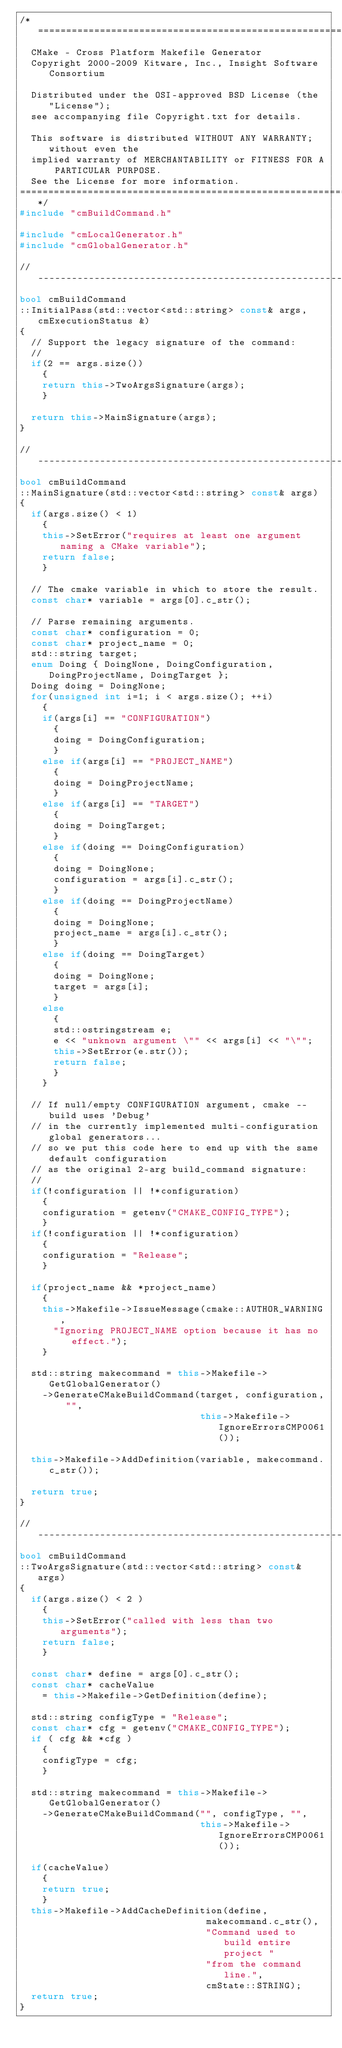Convert code to text. <code><loc_0><loc_0><loc_500><loc_500><_C++_>/*============================================================================
  CMake - Cross Platform Makefile Generator
  Copyright 2000-2009 Kitware, Inc., Insight Software Consortium

  Distributed under the OSI-approved BSD License (the "License");
  see accompanying file Copyright.txt for details.

  This software is distributed WITHOUT ANY WARRANTY; without even the
  implied warranty of MERCHANTABILITY or FITNESS FOR A PARTICULAR PURPOSE.
  See the License for more information.
============================================================================*/
#include "cmBuildCommand.h"

#include "cmLocalGenerator.h"
#include "cmGlobalGenerator.h"

//----------------------------------------------------------------------
bool cmBuildCommand
::InitialPass(std::vector<std::string> const& args, cmExecutionStatus &)
{
  // Support the legacy signature of the command:
  //
  if(2 == args.size())
    {
    return this->TwoArgsSignature(args);
    }

  return this->MainSignature(args);
}

//----------------------------------------------------------------------
bool cmBuildCommand
::MainSignature(std::vector<std::string> const& args)
{
  if(args.size() < 1)
    {
    this->SetError("requires at least one argument naming a CMake variable");
    return false;
    }

  // The cmake variable in which to store the result.
  const char* variable = args[0].c_str();

  // Parse remaining arguments.
  const char* configuration = 0;
  const char* project_name = 0;
  std::string target;
  enum Doing { DoingNone, DoingConfiguration, DoingProjectName, DoingTarget };
  Doing doing = DoingNone;
  for(unsigned int i=1; i < args.size(); ++i)
    {
    if(args[i] == "CONFIGURATION")
      {
      doing = DoingConfiguration;
      }
    else if(args[i] == "PROJECT_NAME")
      {
      doing = DoingProjectName;
      }
    else if(args[i] == "TARGET")
      {
      doing = DoingTarget;
      }
    else if(doing == DoingConfiguration)
      {
      doing = DoingNone;
      configuration = args[i].c_str();
      }
    else if(doing == DoingProjectName)
      {
      doing = DoingNone;
      project_name = args[i].c_str();
      }
    else if(doing == DoingTarget)
      {
      doing = DoingNone;
      target = args[i];
      }
    else
      {
      std::ostringstream e;
      e << "unknown argument \"" << args[i] << "\"";
      this->SetError(e.str());
      return false;
      }
    }

  // If null/empty CONFIGURATION argument, cmake --build uses 'Debug'
  // in the currently implemented multi-configuration global generators...
  // so we put this code here to end up with the same default configuration
  // as the original 2-arg build_command signature:
  //
  if(!configuration || !*configuration)
    {
    configuration = getenv("CMAKE_CONFIG_TYPE");
    }
  if(!configuration || !*configuration)
    {
    configuration = "Release";
    }

  if(project_name && *project_name)
    {
    this->Makefile->IssueMessage(cmake::AUTHOR_WARNING,
      "Ignoring PROJECT_NAME option because it has no effect.");
    }

  std::string makecommand = this->Makefile->GetGlobalGenerator()
    ->GenerateCMakeBuildCommand(target, configuration, "",
                                this->Makefile->IgnoreErrorsCMP0061());

  this->Makefile->AddDefinition(variable, makecommand.c_str());

  return true;
}

//----------------------------------------------------------------------
bool cmBuildCommand
::TwoArgsSignature(std::vector<std::string> const& args)
{
  if(args.size() < 2 )
    {
    this->SetError("called with less than two arguments");
    return false;
    }

  const char* define = args[0].c_str();
  const char* cacheValue
    = this->Makefile->GetDefinition(define);

  std::string configType = "Release";
  const char* cfg = getenv("CMAKE_CONFIG_TYPE");
  if ( cfg && *cfg )
    {
    configType = cfg;
    }

  std::string makecommand = this->Makefile->GetGlobalGenerator()
    ->GenerateCMakeBuildCommand("", configType, "",
                                this->Makefile->IgnoreErrorsCMP0061());

  if(cacheValue)
    {
    return true;
    }
  this->Makefile->AddCacheDefinition(define,
                                 makecommand.c_str(),
                                 "Command used to build entire project "
                                 "from the command line.",
                                 cmState::STRING);
  return true;
}
</code> 